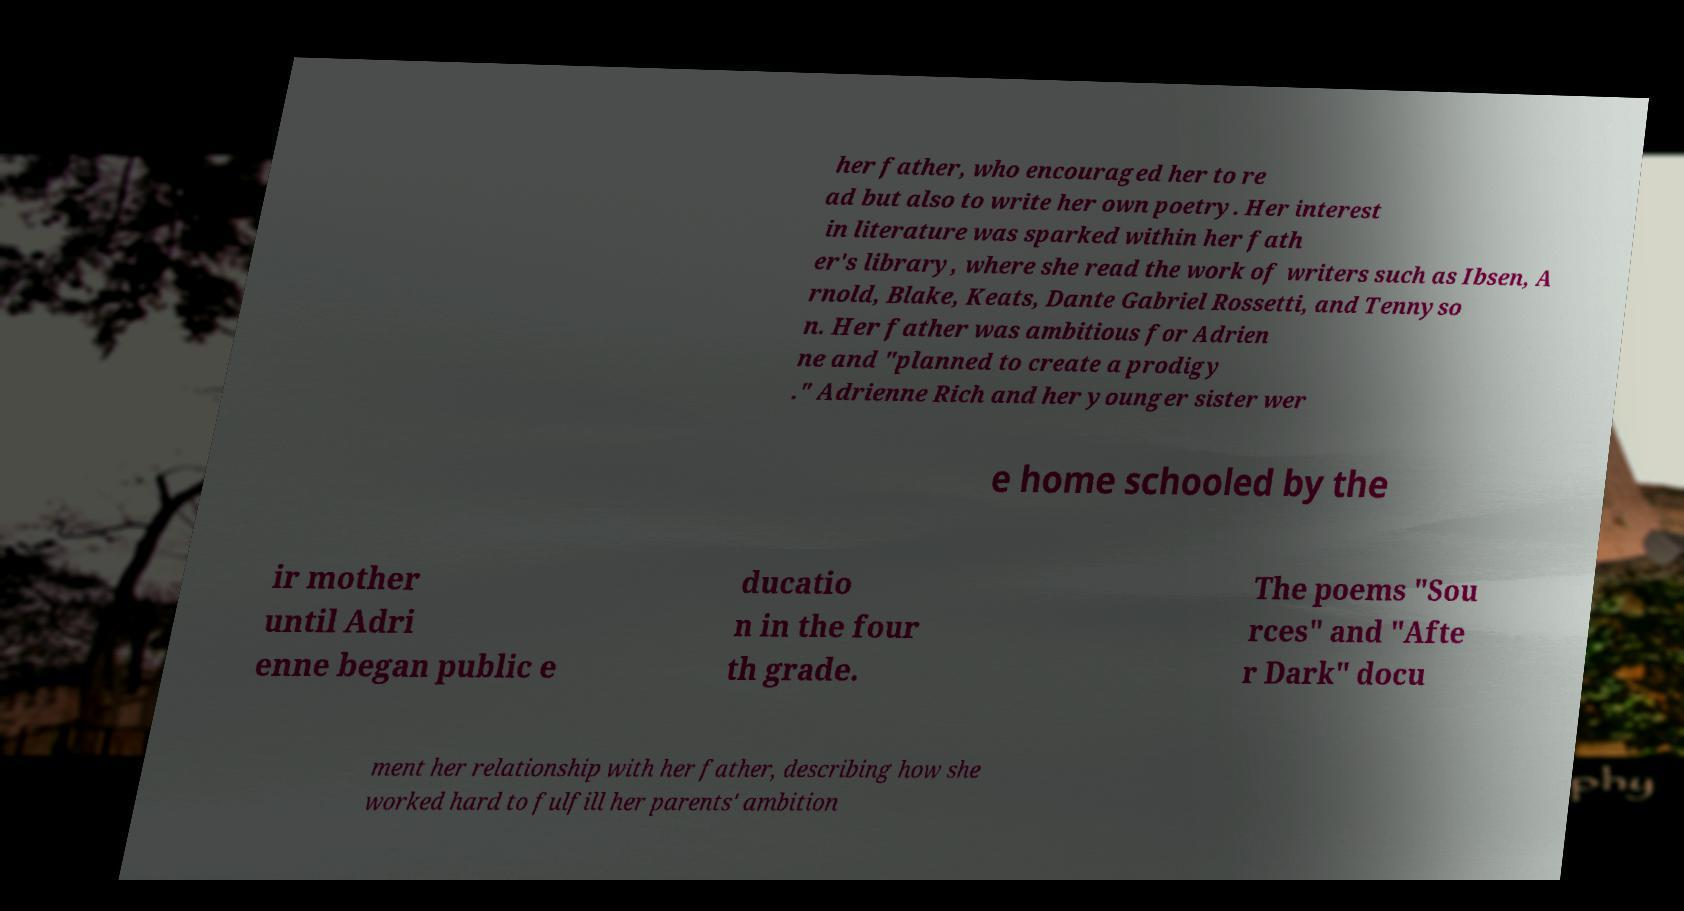Can you read and provide the text displayed in the image?This photo seems to have some interesting text. Can you extract and type it out for me? her father, who encouraged her to re ad but also to write her own poetry. Her interest in literature was sparked within her fath er's library, where she read the work of writers such as Ibsen, A rnold, Blake, Keats, Dante Gabriel Rossetti, and Tennyso n. Her father was ambitious for Adrien ne and "planned to create a prodigy ." Adrienne Rich and her younger sister wer e home schooled by the ir mother until Adri enne began public e ducatio n in the four th grade. The poems "Sou rces" and "Afte r Dark" docu ment her relationship with her father, describing how she worked hard to fulfill her parents' ambition 